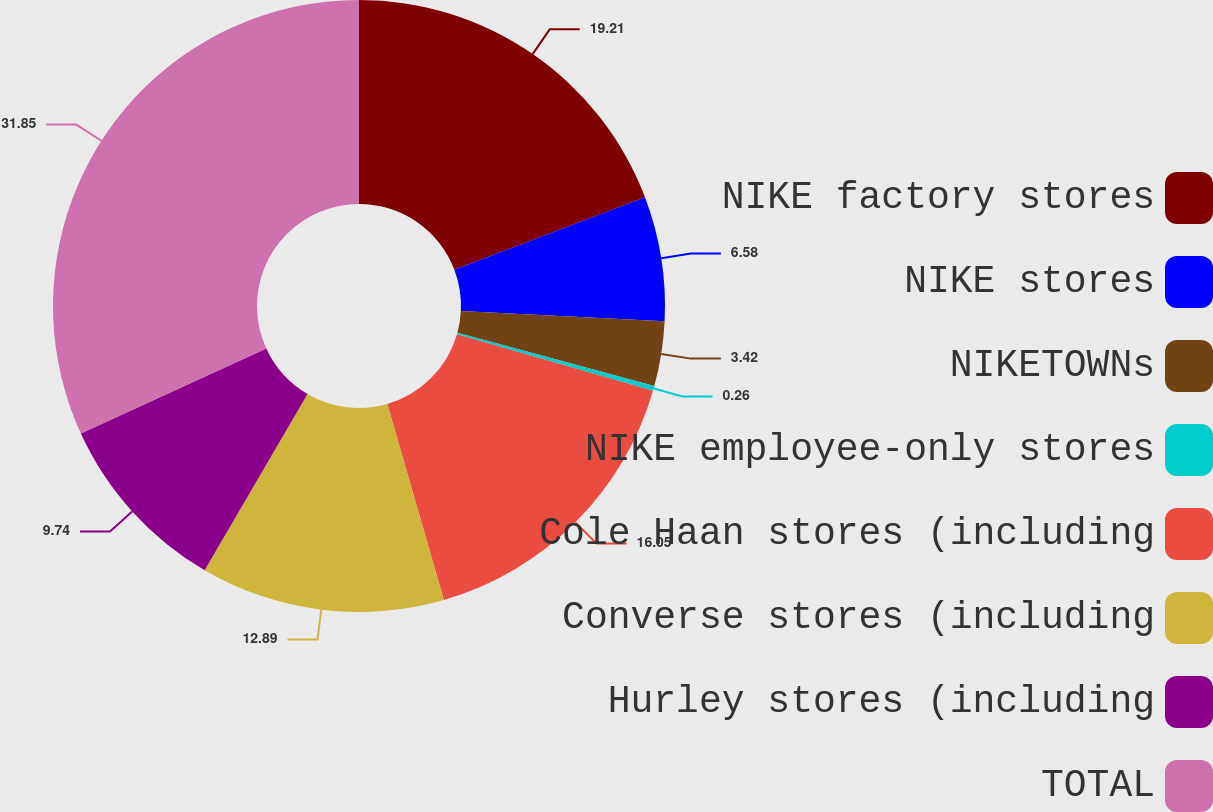Convert chart to OTSL. <chart><loc_0><loc_0><loc_500><loc_500><pie_chart><fcel>NIKE factory stores<fcel>NIKE stores<fcel>NIKETOWNs<fcel>NIKE employee-only stores<fcel>Cole Haan stores (including<fcel>Converse stores (including<fcel>Hurley stores (including<fcel>TOTAL<nl><fcel>19.21%<fcel>6.58%<fcel>3.42%<fcel>0.26%<fcel>16.05%<fcel>12.89%<fcel>9.74%<fcel>31.84%<nl></chart> 